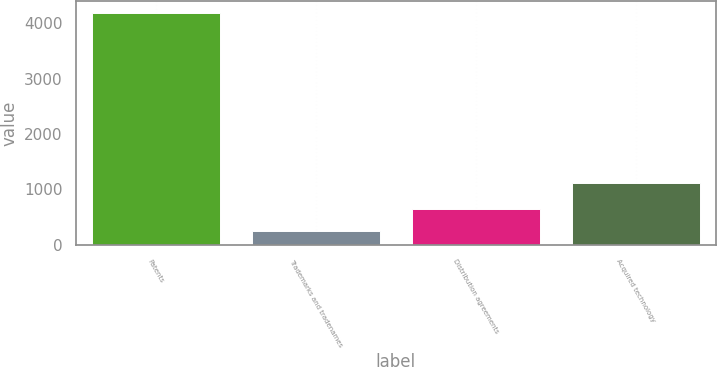Convert chart. <chart><loc_0><loc_0><loc_500><loc_500><bar_chart><fcel>Patents<fcel>Trademarks and tradenames<fcel>Distribution agreements<fcel>Acquired technology<nl><fcel>4192<fcel>259<fcel>652.3<fcel>1112<nl></chart> 